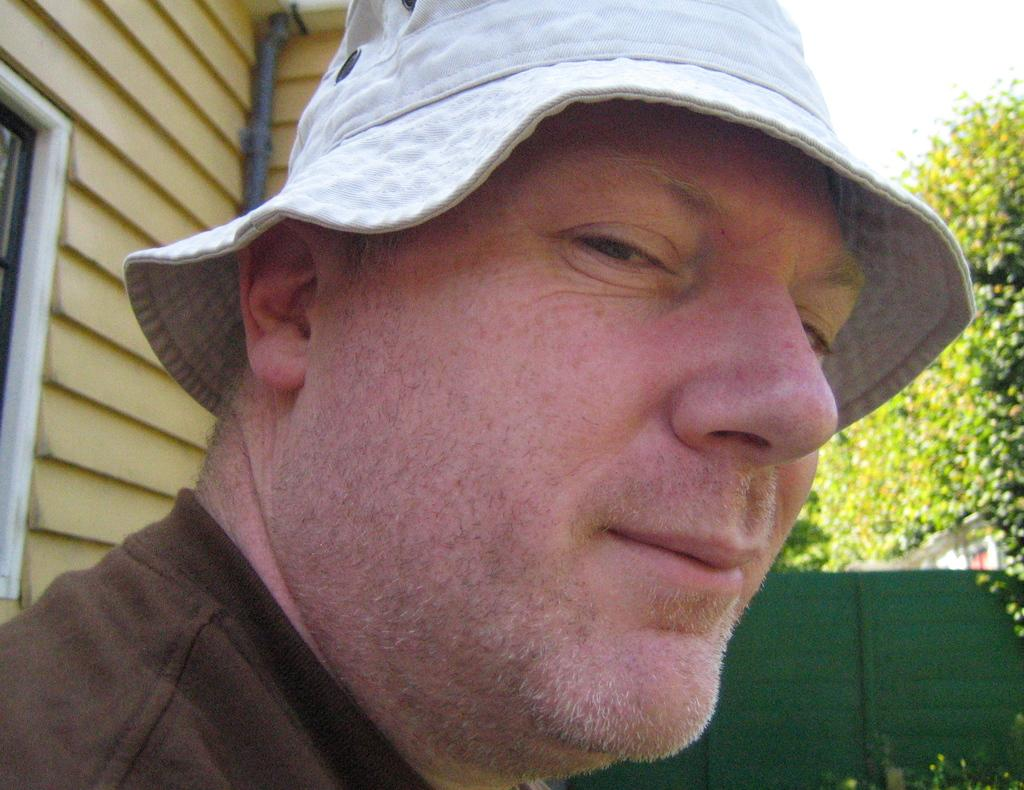What is the main subject of the image? There is a person in the image. What is the person wearing on their upper body? The person is wearing a brown shirt. What type of headwear is the person wearing? The person is wearing a cap. What can be seen in the background of the image? There is a house with a window and trees in the background of the image. What architectural feature is present on the right side of the image? There is a fence on the right side of the image. What part of the natural environment is visible at the top right of the image? The sky is visible at the top right of the image. How many cherries are on the person's shirt in the image? There are no cherries visible on the person's shirt in the image. Is there any snow visible in the image? There is no snow present in the image. 